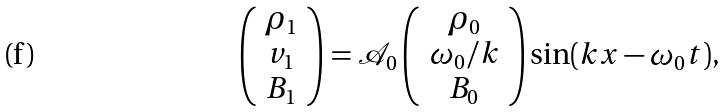<formula> <loc_0><loc_0><loc_500><loc_500>\left ( \begin{array} { c } \rho _ { 1 } \\ v _ { 1 } \\ B _ { 1 } \end{array} \right ) = \mathcal { A } _ { 0 } \left ( \begin{array} { c } \rho _ { 0 } \\ \omega _ { 0 } / k \\ B _ { 0 } \end{array} \right ) \sin ( k x - \omega _ { 0 } t ) ,</formula> 